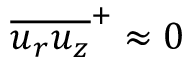Convert formula to latex. <formula><loc_0><loc_0><loc_500><loc_500>\overline { { u _ { r } u _ { z } } } ^ { + } \approx 0</formula> 